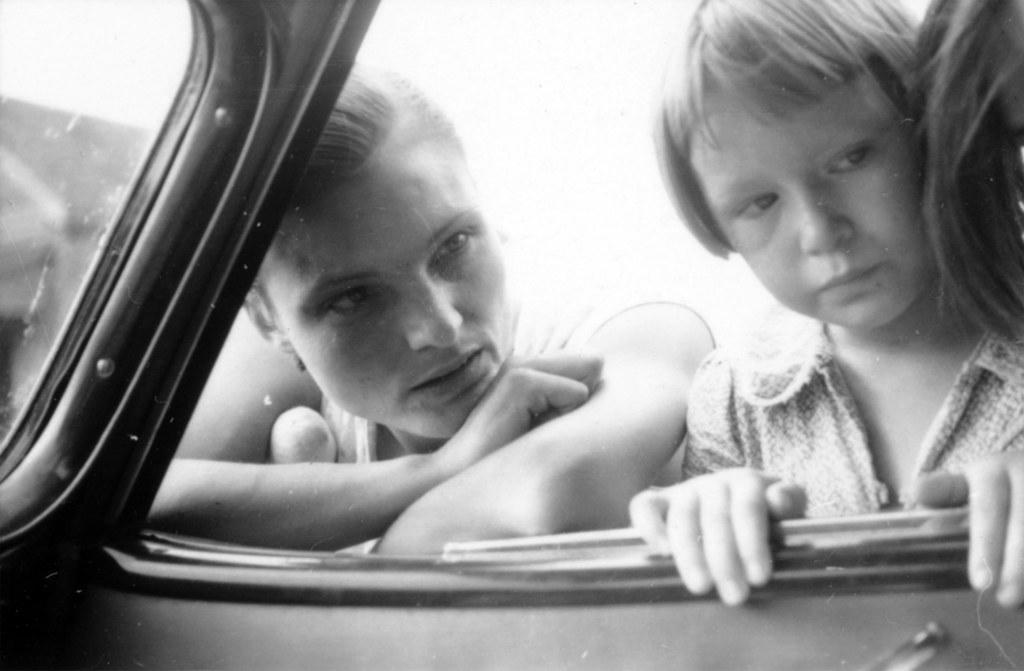How would you summarize this image in a sentence or two? A black and white picture. These 2 persons are standing and staring. 